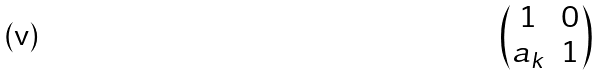Convert formula to latex. <formula><loc_0><loc_0><loc_500><loc_500>\begin{pmatrix} 1 & 0 \\ a _ { k } & 1 \end{pmatrix}</formula> 